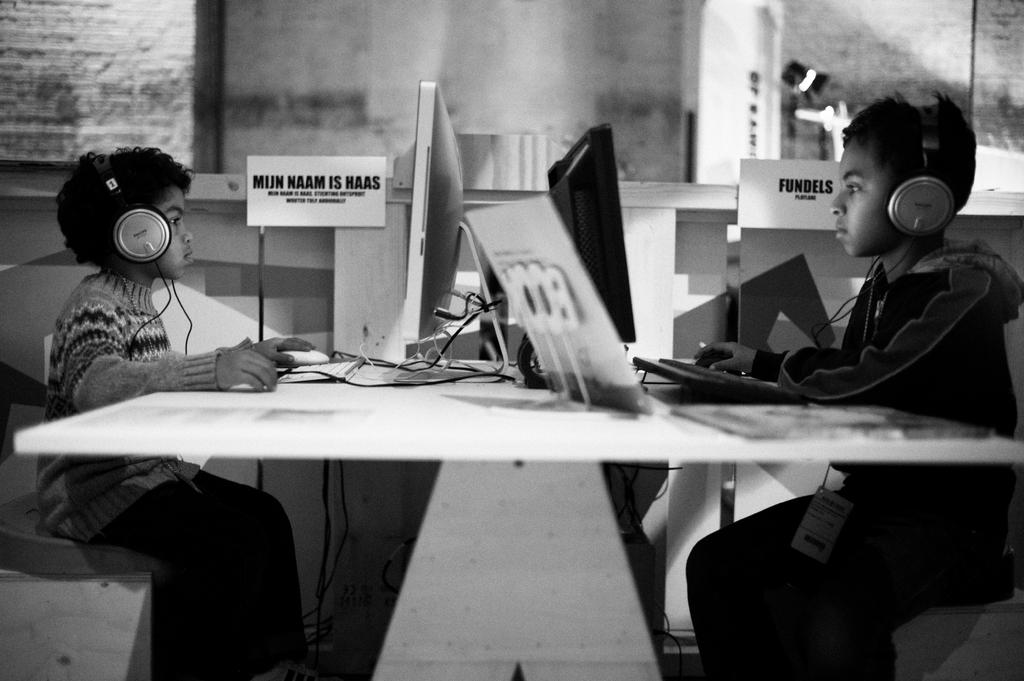What electronic device is visible in the image? There is a laptop in the image. What piece of furniture is present in the image? There is a table in the image. What type of decoration is on the wall in the image? There is a poster in the image. How many people are in the image? There are two people in the image. What are the two people doing in the image? The two people are sitting on chairs. What type of tin can be seen in the image? There is no tin present in the image. Can you describe the zephyr in the image? There is no zephyr present in the image; it is a term related to wind, and there is no mention of wind or weather in the provided facts. 